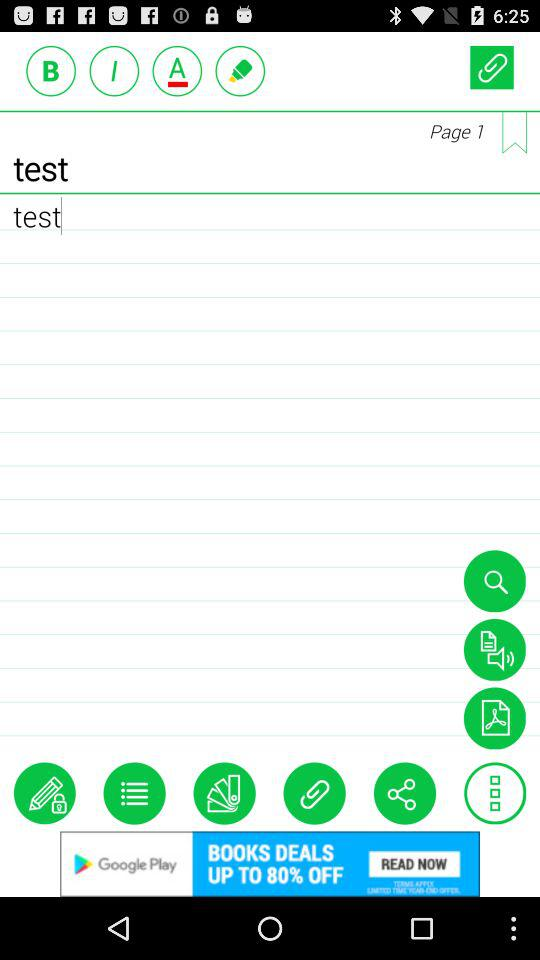How many more bookmarks are there than chats?
Answer the question using a single word or phrase. 1 